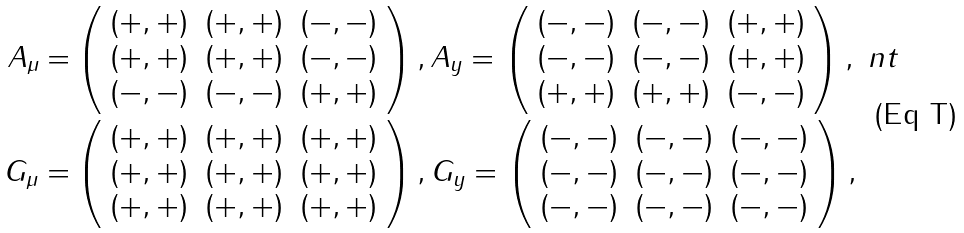<formula> <loc_0><loc_0><loc_500><loc_500>A _ { \mu } = & \left ( \begin{array} { c c c } ( + , + ) & ( + , + ) & ( - , - ) \\ ( + , + ) & ( + , + ) & ( - , - ) \\ ( - , - ) & ( - , - ) & ( + , + ) \end{array} \right ) , A _ { y } = \left ( \begin{array} { c c c } ( - , - ) & ( - , - ) & ( + , + ) \\ ( - , - ) & ( - , - ) & ( + , + ) \\ ( + , + ) & ( + , + ) & ( - , - ) \end{array} \right ) , \ n t \\ G _ { \mu } = & \left ( \begin{array} { c c c } ( + , + ) & ( + , + ) & ( + , + ) \\ ( + , + ) & ( + , + ) & ( + , + ) \\ ( + , + ) & ( + , + ) & ( + , + ) \end{array} \right ) , G _ { y } = \left ( \begin{array} { c c c } ( - , - ) & ( - , - ) & ( - , - ) \\ ( - , - ) & ( - , - ) & ( - , - ) \\ ( - , - ) & ( - , - ) & ( - , - ) \end{array} \right ) ,</formula> 